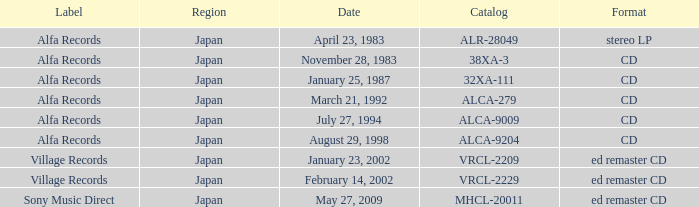Which date is in CD format? November 28, 1983, January 25, 1987, March 21, 1992, July 27, 1994, August 29, 1998. 